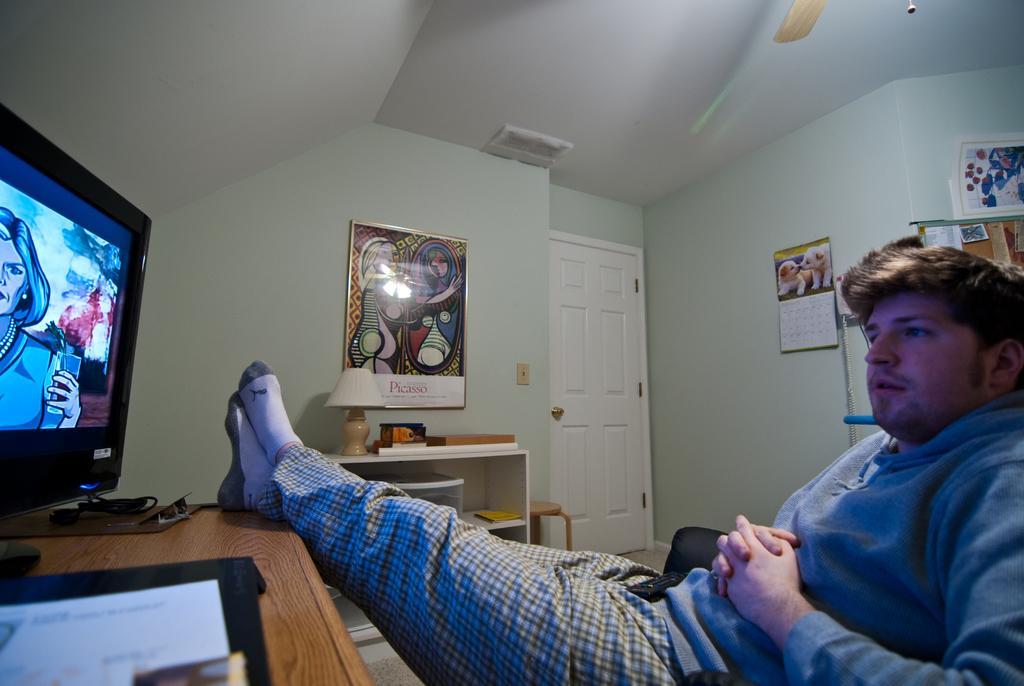Please provide a concise description of this image. In the image there is a man sitting and he kept his legs on the table. On the left corner of the image there is a table with a screen and some other objects. Beside him there is a cupboard with lamp and some other things. Behind the cupboard there is a wall with frame. And also there is a door. On the right side of the image there is a wall with calendar and some other things. At the top of the image there is a fan wing. 